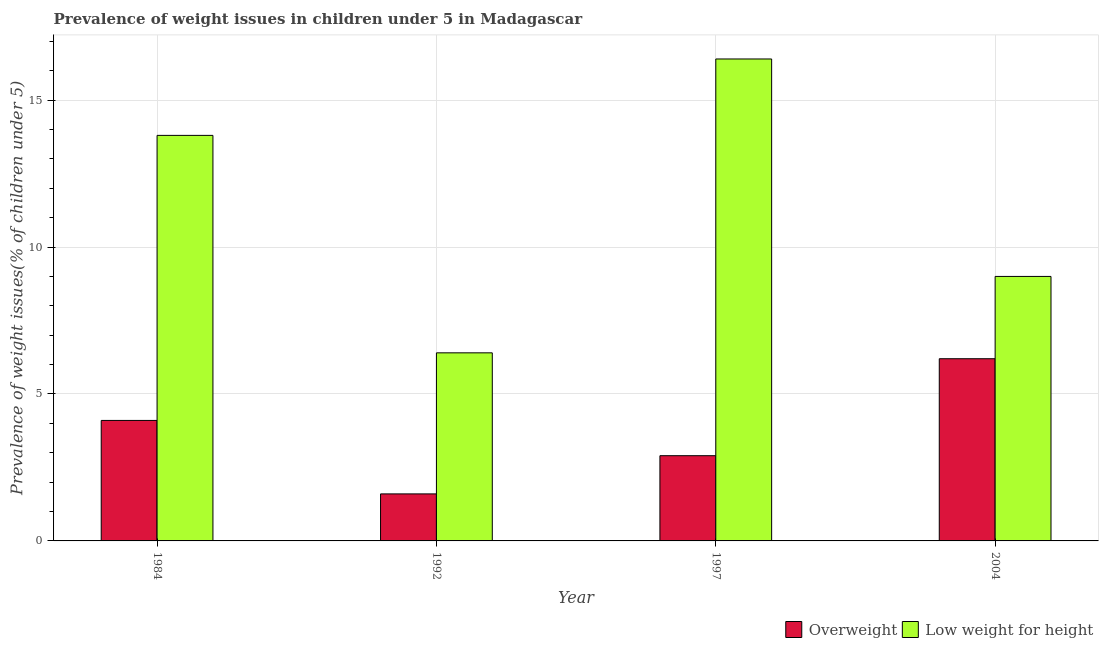How many different coloured bars are there?
Your response must be concise. 2. How many bars are there on the 3rd tick from the left?
Ensure brevity in your answer.  2. In how many cases, is the number of bars for a given year not equal to the number of legend labels?
Offer a terse response. 0. What is the percentage of overweight children in 1997?
Offer a terse response. 2.9. Across all years, what is the maximum percentage of overweight children?
Ensure brevity in your answer.  6.2. Across all years, what is the minimum percentage of underweight children?
Your answer should be very brief. 6.4. In which year was the percentage of underweight children maximum?
Your answer should be very brief. 1997. What is the total percentage of overweight children in the graph?
Offer a very short reply. 14.8. What is the difference between the percentage of underweight children in 1992 and that in 1997?
Offer a very short reply. -10. What is the difference between the percentage of underweight children in 1984 and the percentage of overweight children in 2004?
Ensure brevity in your answer.  4.8. What is the average percentage of overweight children per year?
Give a very brief answer. 3.7. In the year 1997, what is the difference between the percentage of overweight children and percentage of underweight children?
Your response must be concise. 0. What is the ratio of the percentage of underweight children in 1992 to that in 1997?
Your response must be concise. 0.39. Is the difference between the percentage of overweight children in 1997 and 2004 greater than the difference between the percentage of underweight children in 1997 and 2004?
Your answer should be compact. No. What is the difference between the highest and the second highest percentage of underweight children?
Offer a very short reply. 2.6. What is the difference between the highest and the lowest percentage of overweight children?
Your answer should be compact. 4.6. What does the 2nd bar from the left in 1992 represents?
Keep it short and to the point. Low weight for height. What does the 2nd bar from the right in 1984 represents?
Your response must be concise. Overweight. How many years are there in the graph?
Keep it short and to the point. 4. Does the graph contain any zero values?
Give a very brief answer. No. Where does the legend appear in the graph?
Ensure brevity in your answer.  Bottom right. How are the legend labels stacked?
Provide a short and direct response. Horizontal. What is the title of the graph?
Your answer should be compact. Prevalence of weight issues in children under 5 in Madagascar. Does "Time to export" appear as one of the legend labels in the graph?
Ensure brevity in your answer.  No. What is the label or title of the Y-axis?
Give a very brief answer. Prevalence of weight issues(% of children under 5). What is the Prevalence of weight issues(% of children under 5) in Overweight in 1984?
Keep it short and to the point. 4.1. What is the Prevalence of weight issues(% of children under 5) of Low weight for height in 1984?
Your answer should be compact. 13.8. What is the Prevalence of weight issues(% of children under 5) of Overweight in 1992?
Offer a terse response. 1.6. What is the Prevalence of weight issues(% of children under 5) of Low weight for height in 1992?
Keep it short and to the point. 6.4. What is the Prevalence of weight issues(% of children under 5) in Overweight in 1997?
Keep it short and to the point. 2.9. What is the Prevalence of weight issues(% of children under 5) of Low weight for height in 1997?
Provide a short and direct response. 16.4. What is the Prevalence of weight issues(% of children under 5) of Overweight in 2004?
Your response must be concise. 6.2. What is the Prevalence of weight issues(% of children under 5) in Low weight for height in 2004?
Your answer should be compact. 9. Across all years, what is the maximum Prevalence of weight issues(% of children under 5) in Overweight?
Offer a very short reply. 6.2. Across all years, what is the maximum Prevalence of weight issues(% of children under 5) of Low weight for height?
Provide a short and direct response. 16.4. Across all years, what is the minimum Prevalence of weight issues(% of children under 5) in Overweight?
Keep it short and to the point. 1.6. Across all years, what is the minimum Prevalence of weight issues(% of children under 5) of Low weight for height?
Offer a terse response. 6.4. What is the total Prevalence of weight issues(% of children under 5) in Overweight in the graph?
Give a very brief answer. 14.8. What is the total Prevalence of weight issues(% of children under 5) of Low weight for height in the graph?
Ensure brevity in your answer.  45.6. What is the difference between the Prevalence of weight issues(% of children under 5) in Low weight for height in 1984 and that in 1992?
Keep it short and to the point. 7.4. What is the difference between the Prevalence of weight issues(% of children under 5) of Overweight in 1984 and that in 2004?
Your answer should be very brief. -2.1. What is the difference between the Prevalence of weight issues(% of children under 5) of Low weight for height in 1992 and that in 2004?
Give a very brief answer. -2.6. What is the difference between the Prevalence of weight issues(% of children under 5) of Low weight for height in 1997 and that in 2004?
Your response must be concise. 7.4. What is the difference between the Prevalence of weight issues(% of children under 5) of Overweight in 1984 and the Prevalence of weight issues(% of children under 5) of Low weight for height in 1992?
Your answer should be very brief. -2.3. What is the difference between the Prevalence of weight issues(% of children under 5) in Overweight in 1992 and the Prevalence of weight issues(% of children under 5) in Low weight for height in 1997?
Make the answer very short. -14.8. What is the difference between the Prevalence of weight issues(% of children under 5) of Overweight in 1992 and the Prevalence of weight issues(% of children under 5) of Low weight for height in 2004?
Offer a terse response. -7.4. What is the difference between the Prevalence of weight issues(% of children under 5) of Overweight in 1997 and the Prevalence of weight issues(% of children under 5) of Low weight for height in 2004?
Your answer should be very brief. -6.1. What is the average Prevalence of weight issues(% of children under 5) in Low weight for height per year?
Your response must be concise. 11.4. In the year 1984, what is the difference between the Prevalence of weight issues(% of children under 5) of Overweight and Prevalence of weight issues(% of children under 5) of Low weight for height?
Your answer should be very brief. -9.7. In the year 2004, what is the difference between the Prevalence of weight issues(% of children under 5) of Overweight and Prevalence of weight issues(% of children under 5) of Low weight for height?
Keep it short and to the point. -2.8. What is the ratio of the Prevalence of weight issues(% of children under 5) of Overweight in 1984 to that in 1992?
Keep it short and to the point. 2.56. What is the ratio of the Prevalence of weight issues(% of children under 5) in Low weight for height in 1984 to that in 1992?
Provide a succinct answer. 2.16. What is the ratio of the Prevalence of weight issues(% of children under 5) of Overweight in 1984 to that in 1997?
Ensure brevity in your answer.  1.41. What is the ratio of the Prevalence of weight issues(% of children under 5) in Low weight for height in 1984 to that in 1997?
Ensure brevity in your answer.  0.84. What is the ratio of the Prevalence of weight issues(% of children under 5) in Overweight in 1984 to that in 2004?
Ensure brevity in your answer.  0.66. What is the ratio of the Prevalence of weight issues(% of children under 5) of Low weight for height in 1984 to that in 2004?
Your answer should be compact. 1.53. What is the ratio of the Prevalence of weight issues(% of children under 5) in Overweight in 1992 to that in 1997?
Provide a succinct answer. 0.55. What is the ratio of the Prevalence of weight issues(% of children under 5) in Low weight for height in 1992 to that in 1997?
Your answer should be compact. 0.39. What is the ratio of the Prevalence of weight issues(% of children under 5) in Overweight in 1992 to that in 2004?
Your answer should be compact. 0.26. What is the ratio of the Prevalence of weight issues(% of children under 5) in Low weight for height in 1992 to that in 2004?
Ensure brevity in your answer.  0.71. What is the ratio of the Prevalence of weight issues(% of children under 5) in Overweight in 1997 to that in 2004?
Offer a very short reply. 0.47. What is the ratio of the Prevalence of weight issues(% of children under 5) of Low weight for height in 1997 to that in 2004?
Your response must be concise. 1.82. What is the difference between the highest and the second highest Prevalence of weight issues(% of children under 5) in Overweight?
Provide a succinct answer. 2.1. 